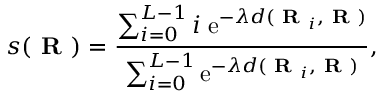<formula> <loc_0><loc_0><loc_500><loc_500>s ( R ) = \frac { \sum _ { i = 0 } ^ { L - 1 } i \, e ^ { - \lambda d ( R _ { i } , R ) } } { \sum _ { i = 0 } ^ { L - 1 } e ^ { - \lambda d ( R _ { i } , R ) } } ,</formula> 